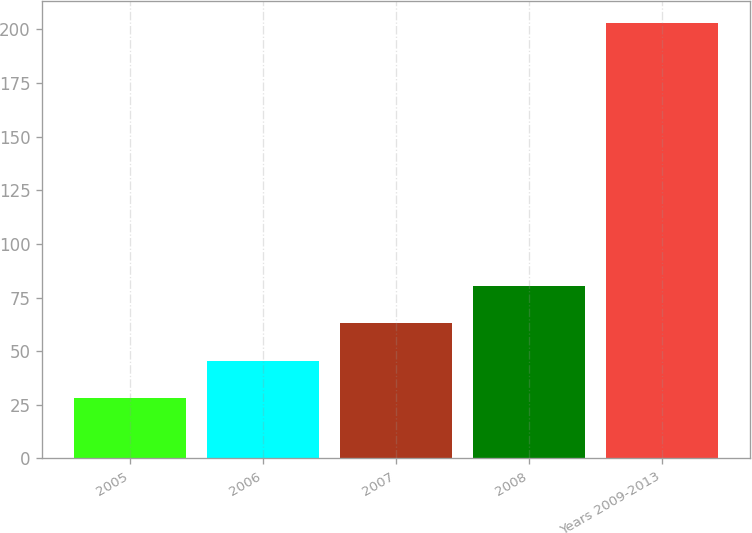Convert chart to OTSL. <chart><loc_0><loc_0><loc_500><loc_500><bar_chart><fcel>2005<fcel>2006<fcel>2007<fcel>2008<fcel>Years 2009-2013<nl><fcel>28<fcel>45.5<fcel>63<fcel>80.5<fcel>203<nl></chart> 